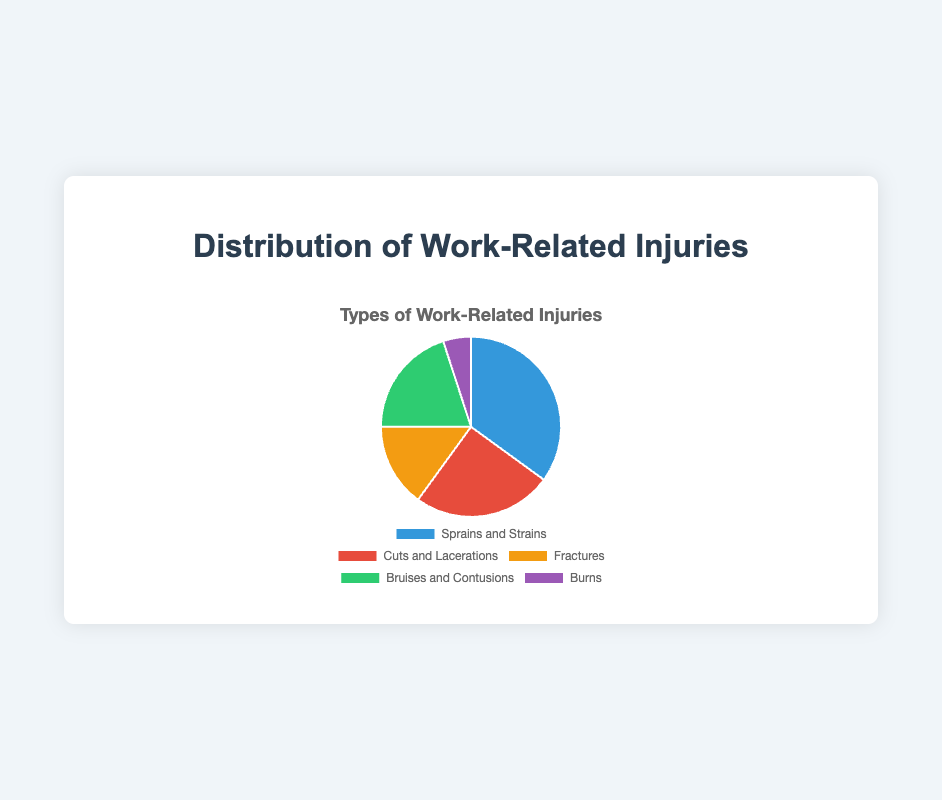What's the most common type of work-related injury? From the pie chart, the biggest section is 'Sprains and Strains', indicating it has the highest number of incidents.
Answer: Sprains and Strains Which type of injury has the fewest incidents? The smallest section of the pie chart is 'Burns', so it has the fewest incidents.
Answer: Burns How many more incidents are there of Sprains and Strains compared to Fractures? Sprains and Strains have 35 incidents, and Fractures have 15. The difference is 35 - 15 = 20 incidents.
Answer: 20 What is the total number of incidents for Cuts and Lacerations and Bruises and Contusions combined? Cuts and Lacerations have 25 incidents, and Bruises and Contusions have 20. Combined, they total 25 + 20 = 45 incidents.
Answer: 45 Are there more incidents of Cuts and Lacerations than Bruises and Contusions? Yes, the section for Cuts and Lacerations is larger than that of Bruises and Contusions, meaning there are more incidents.
Answer: Yes What percentage of the total incidents are accounted for by Burns? Burns have 5 incidents and the total number of incidents is 100. Therefore, Burns account for (5/100) * 100% = 5%.
Answer: 5% Which color represents Fractures on the pie chart? The section for Fractures is 'Fractures', which is typically represented in yellow based on the chart's color scheme.
Answer: Yellow What is the combined proportion of Sprains and Strains and Cuts and Lacerations compared to the total? Sprains and Strains have 35 incidents and Cuts and Lacerations have 25. Combined they have 35 + 25 = 60 incidents, which is 60% of the total.
Answer: 60% How do Bruises and Contusions compare to Cuts and Lacerations in terms of incidents? Bruises and Contusions have 20 incidents, while Cuts and Lacerations have 25, so Cuts and Lacerations have 5 more incidents.
Answer: Cuts and Lacerations have 5 more incidents What's the ratio of Sprains and Strains to Burns? Sprains and Strains have 35 incidents, and Burns have 5, so the ratio is 35:5, which simplifies to 7:1.
Answer: 7:1 